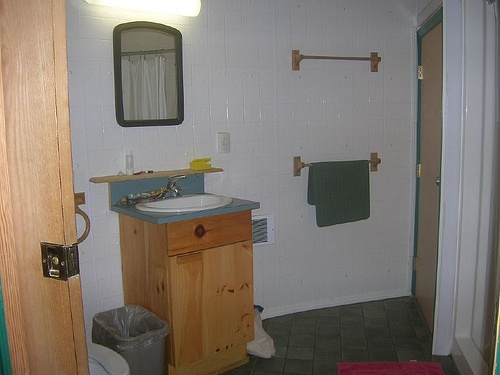Describe the objects in this image and their specific colors. I can see sink in gray, darkgray, and black tones, toilet in gray and black tones, and bottle in gray, darkgray, and black tones in this image. 